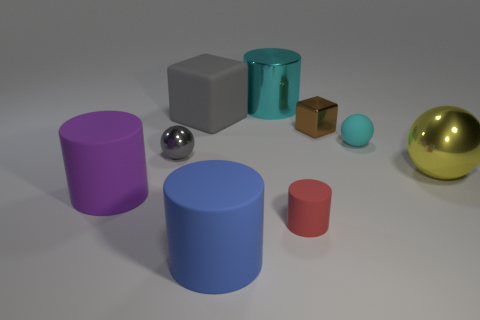The large shiny object that is the same color as the rubber sphere is what shape?
Provide a short and direct response. Cylinder. What is the material of the small thing to the left of the large cyan metallic cylinder?
Provide a short and direct response. Metal. Does the small metallic thing in front of the tiny cyan sphere have the same color as the large matte block?
Offer a terse response. Yes. Are there more objects that are behind the large blue cylinder than large gray rubber blocks behind the large gray rubber block?
Offer a very short reply. Yes. Is there anything else of the same color as the big ball?
Provide a short and direct response. No. How many things are either large rubber cylinders or brown matte things?
Ensure brevity in your answer.  2. Is the size of the yellow shiny thing that is in front of the gray ball the same as the tiny cyan matte thing?
Provide a short and direct response. No. What number of other objects are the same size as the rubber cube?
Keep it short and to the point. 4. Is there a purple rubber cylinder?
Offer a very short reply. Yes. What size is the gray thing that is in front of the small matte thing that is behind the red object?
Give a very brief answer. Small. 